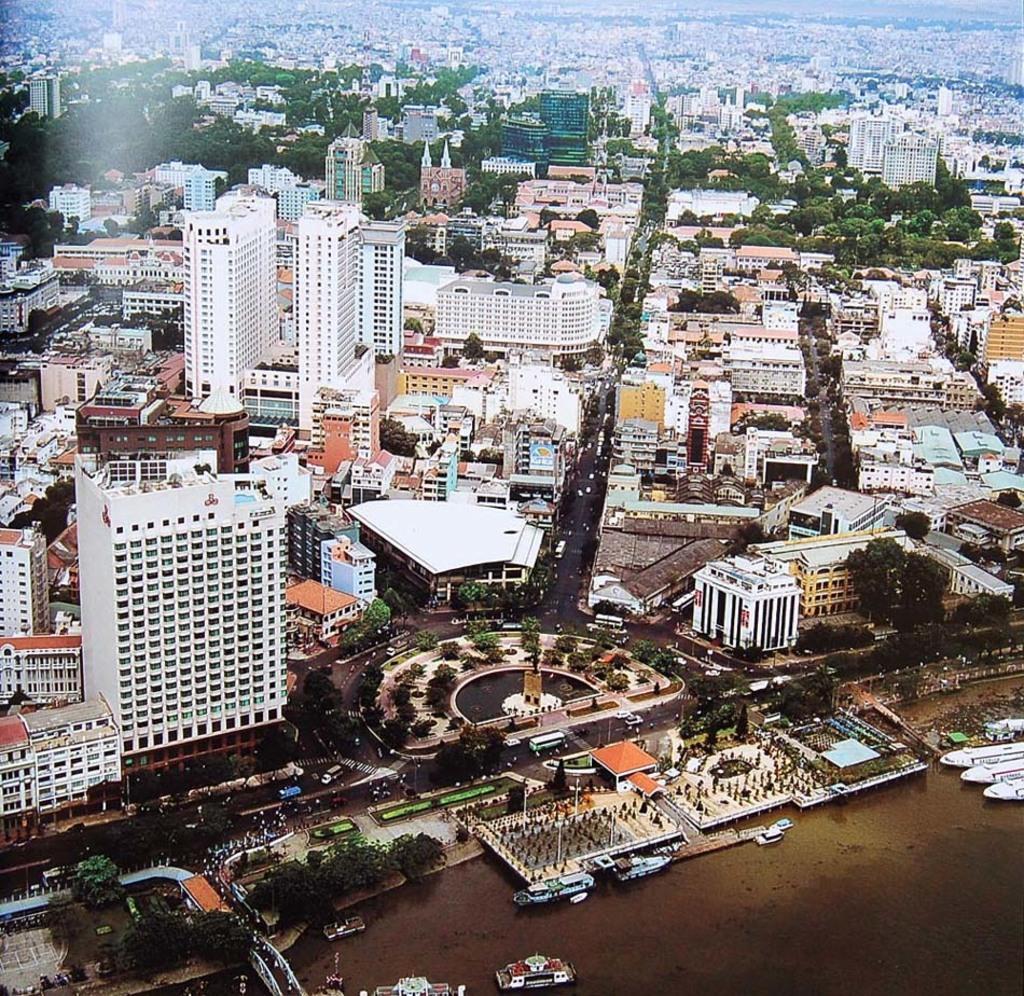In one or two sentences, can you explain what this image depicts? In this picture we can see boats above the water, buildings, trees, poles and vehicles on the road. 